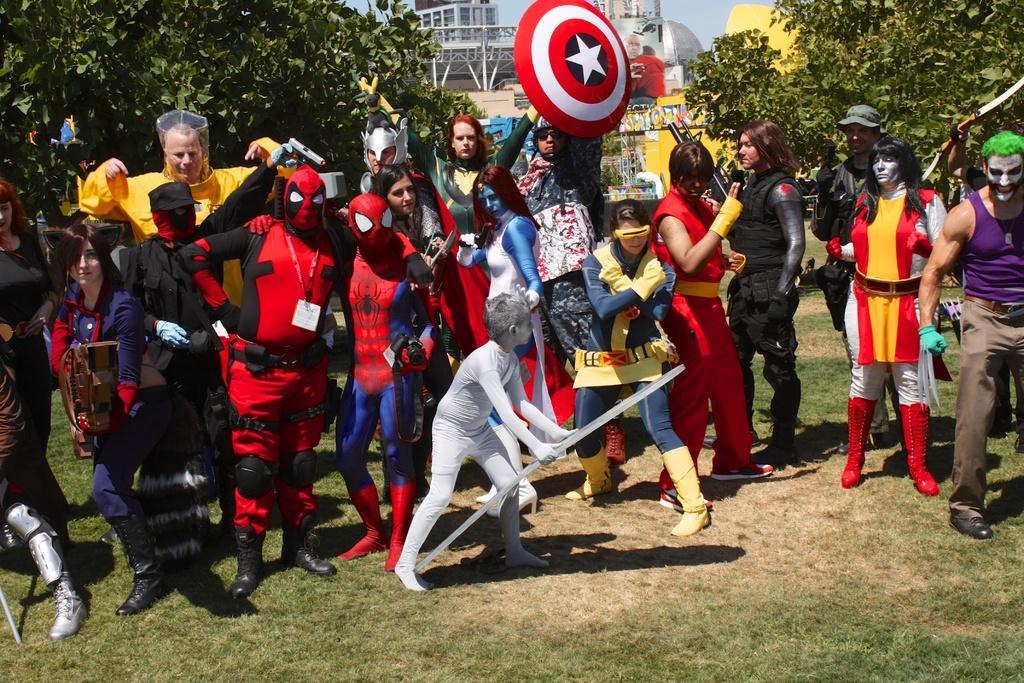How would you summarize this image in a sentence or two? At the bottom of the image there is grass. In the middle of the image few people are standing and holding something in their hands. Behind them there are some trees and buildings. 